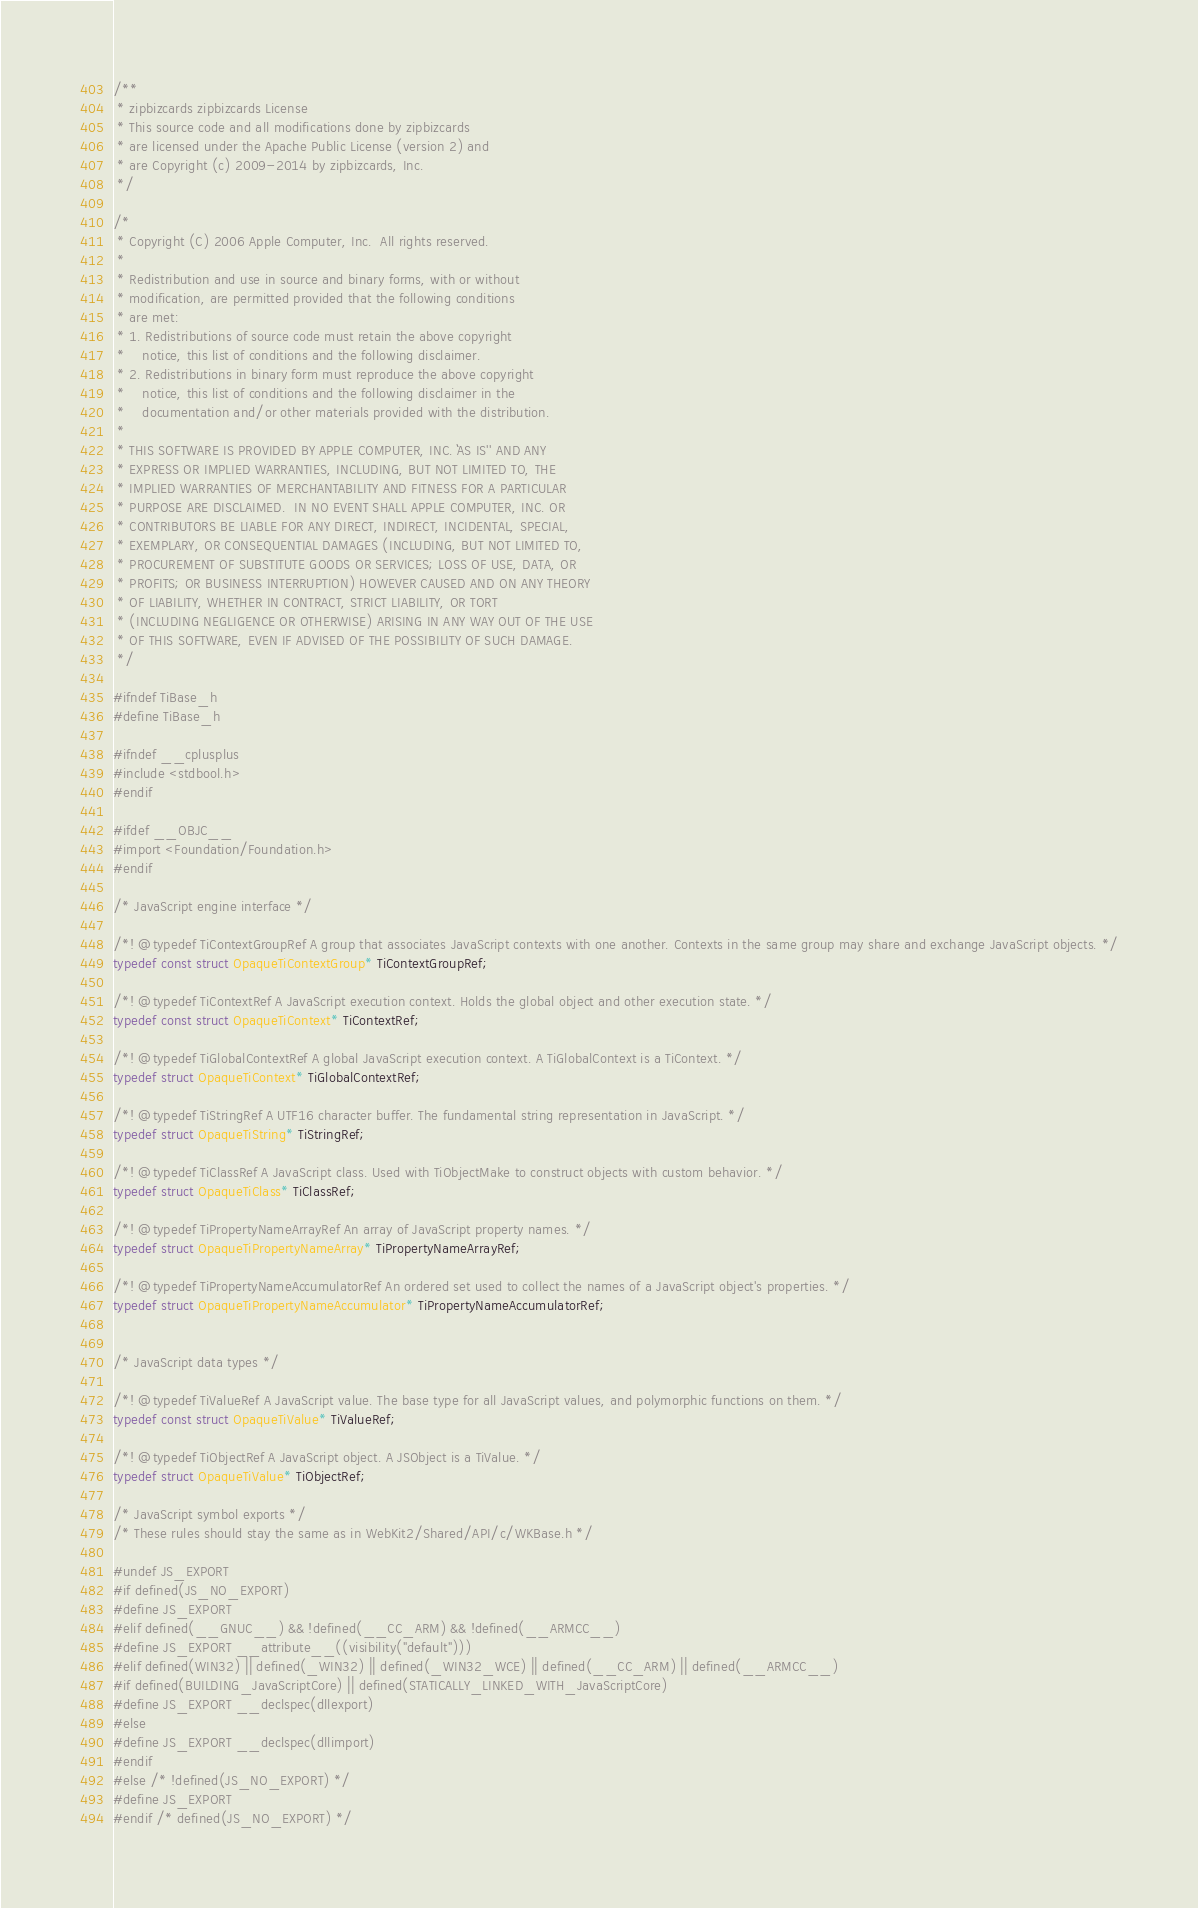Convert code to text. <code><loc_0><loc_0><loc_500><loc_500><_C_>/**
 * zipbizcards zipbizcards License
 * This source code and all modifications done by zipbizcards
 * are licensed under the Apache Public License (version 2) and
 * are Copyright (c) 2009-2014 by zipbizcards, Inc.
 */

/*
 * Copyright (C) 2006 Apple Computer, Inc.  All rights reserved.
 *
 * Redistribution and use in source and binary forms, with or without
 * modification, are permitted provided that the following conditions
 * are met:
 * 1. Redistributions of source code must retain the above copyright
 *    notice, this list of conditions and the following disclaimer.
 * 2. Redistributions in binary form must reproduce the above copyright
 *    notice, this list of conditions and the following disclaimer in the
 *    documentation and/or other materials provided with the distribution.
 *
 * THIS SOFTWARE IS PROVIDED BY APPLE COMPUTER, INC. ``AS IS'' AND ANY
 * EXPRESS OR IMPLIED WARRANTIES, INCLUDING, BUT NOT LIMITED TO, THE
 * IMPLIED WARRANTIES OF MERCHANTABILITY AND FITNESS FOR A PARTICULAR
 * PURPOSE ARE DISCLAIMED.  IN NO EVENT SHALL APPLE COMPUTER, INC. OR
 * CONTRIBUTORS BE LIABLE FOR ANY DIRECT, INDIRECT, INCIDENTAL, SPECIAL,
 * EXEMPLARY, OR CONSEQUENTIAL DAMAGES (INCLUDING, BUT NOT LIMITED TO,
 * PROCUREMENT OF SUBSTITUTE GOODS OR SERVICES; LOSS OF USE, DATA, OR
 * PROFITS; OR BUSINESS INTERRUPTION) HOWEVER CAUSED AND ON ANY THEORY
 * OF LIABILITY, WHETHER IN CONTRACT, STRICT LIABILITY, OR TORT
 * (INCLUDING NEGLIGENCE OR OTHERWISE) ARISING IN ANY WAY OUT OF THE USE
 * OF THIS SOFTWARE, EVEN IF ADVISED OF THE POSSIBILITY OF SUCH DAMAGE. 
 */

#ifndef TiBase_h
#define TiBase_h

#ifndef __cplusplus
#include <stdbool.h>
#endif

#ifdef __OBJC__
#import <Foundation/Foundation.h>
#endif

/* JavaScript engine interface */

/*! @typedef TiContextGroupRef A group that associates JavaScript contexts with one another. Contexts in the same group may share and exchange JavaScript objects. */
typedef const struct OpaqueTiContextGroup* TiContextGroupRef;

/*! @typedef TiContextRef A JavaScript execution context. Holds the global object and other execution state. */
typedef const struct OpaqueTiContext* TiContextRef;

/*! @typedef TiGlobalContextRef A global JavaScript execution context. A TiGlobalContext is a TiContext. */
typedef struct OpaqueTiContext* TiGlobalContextRef;

/*! @typedef TiStringRef A UTF16 character buffer. The fundamental string representation in JavaScript. */
typedef struct OpaqueTiString* TiStringRef;

/*! @typedef TiClassRef A JavaScript class. Used with TiObjectMake to construct objects with custom behavior. */
typedef struct OpaqueTiClass* TiClassRef;

/*! @typedef TiPropertyNameArrayRef An array of JavaScript property names. */
typedef struct OpaqueTiPropertyNameArray* TiPropertyNameArrayRef;

/*! @typedef TiPropertyNameAccumulatorRef An ordered set used to collect the names of a JavaScript object's properties. */
typedef struct OpaqueTiPropertyNameAccumulator* TiPropertyNameAccumulatorRef;


/* JavaScript data types */

/*! @typedef TiValueRef A JavaScript value. The base type for all JavaScript values, and polymorphic functions on them. */
typedef const struct OpaqueTiValue* TiValueRef;

/*! @typedef TiObjectRef A JavaScript object. A JSObject is a TiValue. */
typedef struct OpaqueTiValue* TiObjectRef;

/* JavaScript symbol exports */
/* These rules should stay the same as in WebKit2/Shared/API/c/WKBase.h */

#undef JS_EXPORT
#if defined(JS_NO_EXPORT)
#define JS_EXPORT
#elif defined(__GNUC__) && !defined(__CC_ARM) && !defined(__ARMCC__)
#define JS_EXPORT __attribute__((visibility("default")))
#elif defined(WIN32) || defined(_WIN32) || defined(_WIN32_WCE) || defined(__CC_ARM) || defined(__ARMCC__)
#if defined(BUILDING_JavaScriptCore) || defined(STATICALLY_LINKED_WITH_JavaScriptCore)
#define JS_EXPORT __declspec(dllexport)
#else
#define JS_EXPORT __declspec(dllimport)
#endif
#else /* !defined(JS_NO_EXPORT) */
#define JS_EXPORT
#endif /* defined(JS_NO_EXPORT) */
</code> 